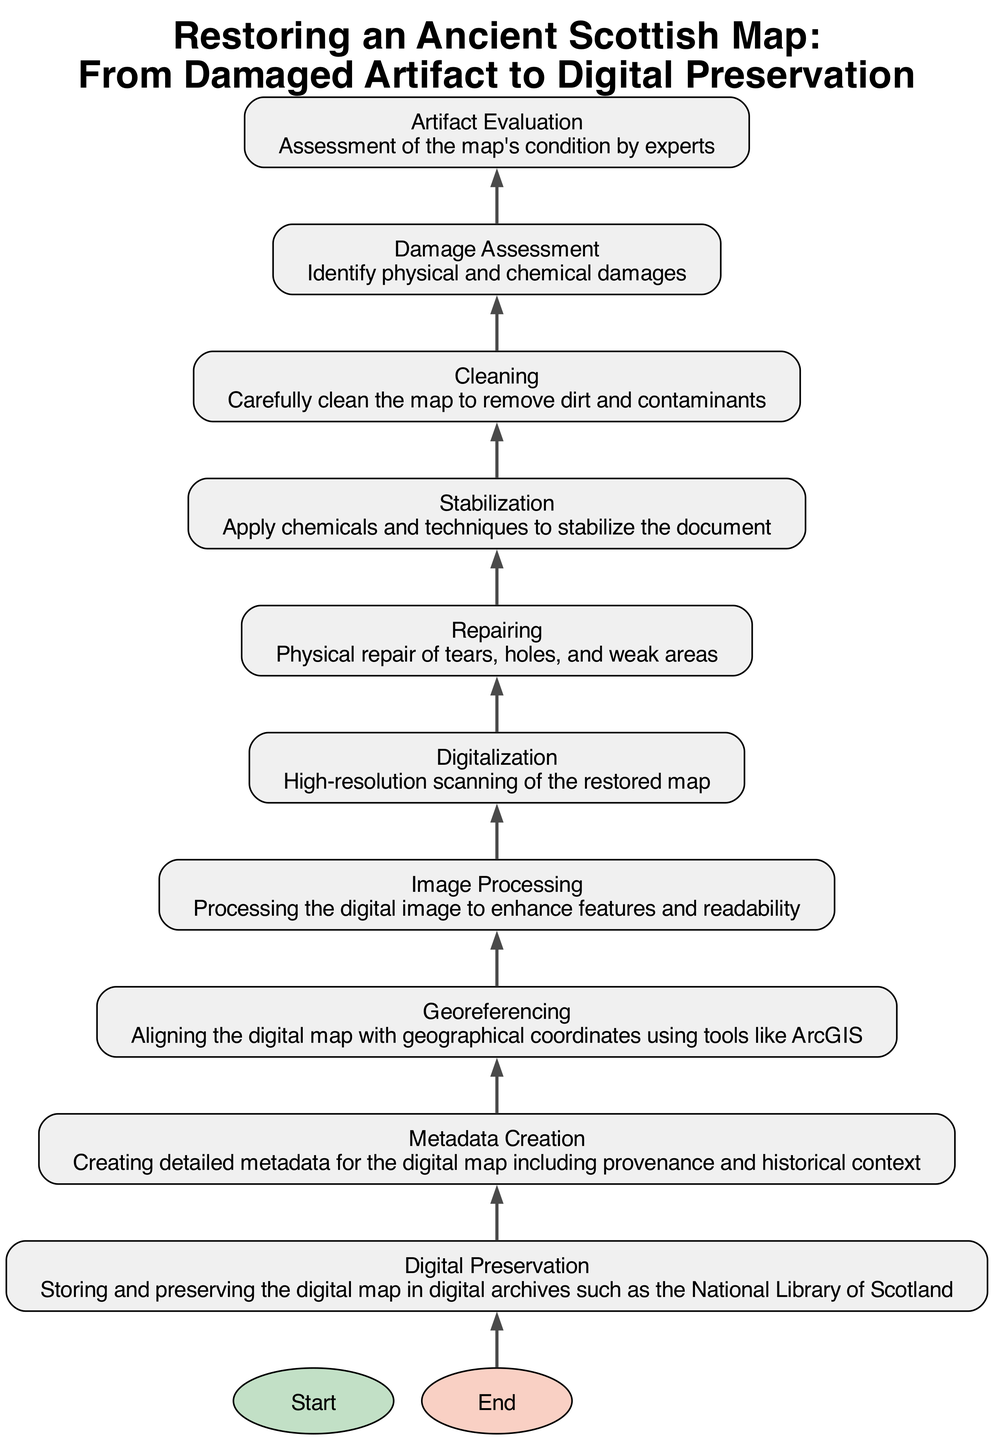What is the first step in the restoration process? The diagram indicates that the first step is "Start," which signifies the initial stage of the entire restoration process for the ancient Scottish map.
Answer: Start How many total steps are in the restoration process? By counting the nodes from "Start" to "End," we have a total of eleven steps that outline the restoration process of the map.
Answer: Eleven What follows the "Digital Preservation" step? According to the flowchart, "Digital Preservation" is followed by the "End" step, indicating the completion of the restoration process.
Answer: End Which step comes after "Cleaning"? "Stabilization" is the step that comes immediately after "Cleaning" in the flowchart, as per the defined order of the restoration process.
Answer: Stabilization What is the main action taken during the "Image Processing" stage? The primary action in the "Image Processing" stage is to enhance features and readability of the scanned digital image of the restored map.
Answer: Enhance features and readability Which step involves creating metadata? The step that involves creating detailed metadata for the digital map, including its provenance and historical context, is referred to as "Metadata Creation."
Answer: Metadata Creation How does the process move from "Repairing" to "Digitalization"? The transition from "Repairing" to "Digitalization" occurs as "Digitalization" is the next step that flows from the completion of the "Repairing" actions taken on the map.
Answer: Flow transition What tool is mentioned in the "Georeferencing" step? The diagram specifies that tools like ArcGIS are used during the "Georeferencing" step for aligning the digital map with geographical coordinates.
Answer: ArcGIS What kind of damage is identified in the "Damage Assessment" stage? The "Damage Assessment" stage focuses on identifying both physical and chemical damages to the ancient map during the evaluation process.
Answer: Physical and chemical damages 